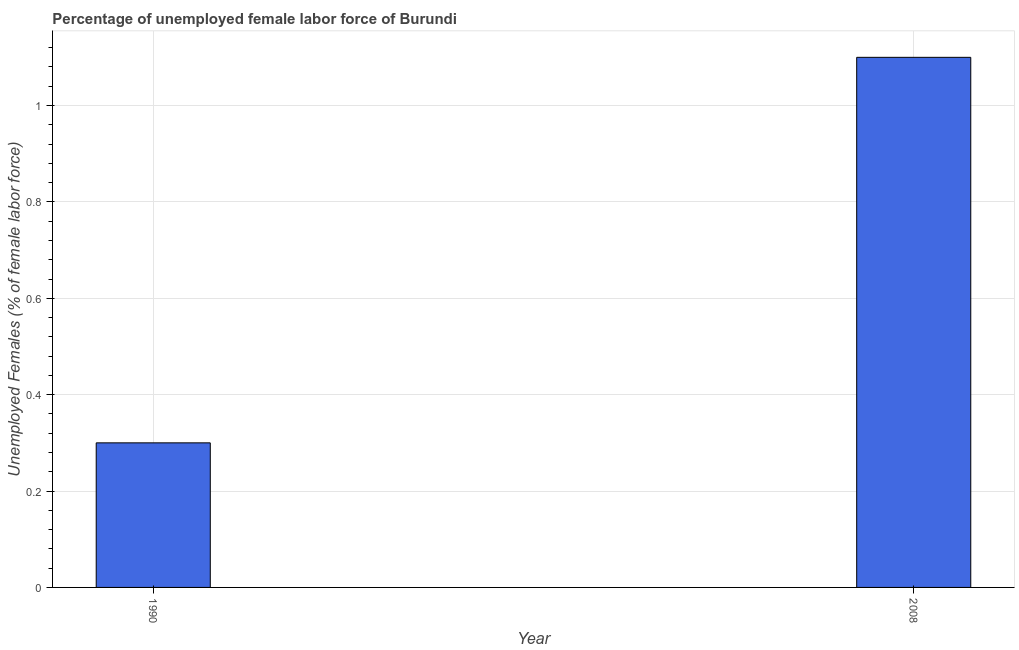What is the title of the graph?
Ensure brevity in your answer.  Percentage of unemployed female labor force of Burundi. What is the label or title of the X-axis?
Your answer should be very brief. Year. What is the label or title of the Y-axis?
Make the answer very short. Unemployed Females (% of female labor force). What is the total unemployed female labour force in 2008?
Your answer should be very brief. 1.1. Across all years, what is the maximum total unemployed female labour force?
Provide a succinct answer. 1.1. Across all years, what is the minimum total unemployed female labour force?
Provide a succinct answer. 0.3. What is the sum of the total unemployed female labour force?
Your answer should be compact. 1.4. What is the median total unemployed female labour force?
Offer a very short reply. 0.7. Do a majority of the years between 1990 and 2008 (inclusive) have total unemployed female labour force greater than 0.84 %?
Your answer should be very brief. No. What is the ratio of the total unemployed female labour force in 1990 to that in 2008?
Make the answer very short. 0.27. Is the total unemployed female labour force in 1990 less than that in 2008?
Make the answer very short. Yes. How many bars are there?
Provide a short and direct response. 2. Are all the bars in the graph horizontal?
Offer a very short reply. No. What is the difference between two consecutive major ticks on the Y-axis?
Offer a very short reply. 0.2. What is the Unemployed Females (% of female labor force) of 1990?
Provide a succinct answer. 0.3. What is the Unemployed Females (% of female labor force) of 2008?
Make the answer very short. 1.1. What is the ratio of the Unemployed Females (% of female labor force) in 1990 to that in 2008?
Your answer should be very brief. 0.27. 